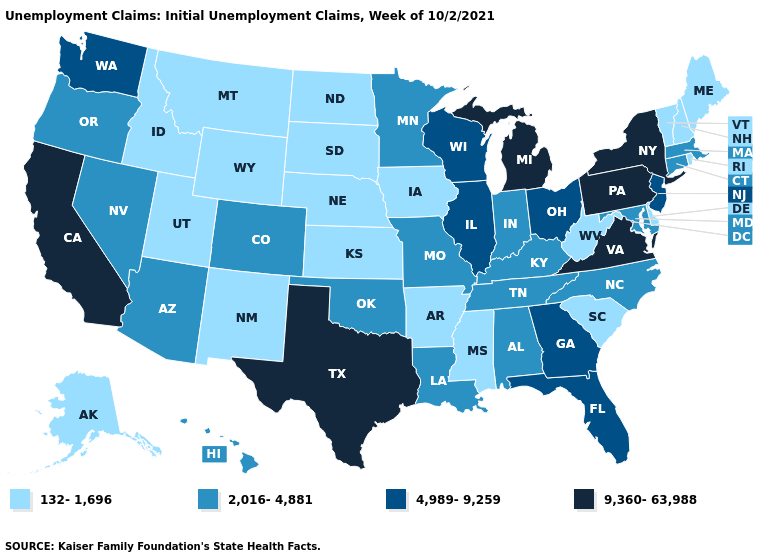Name the states that have a value in the range 9,360-63,988?
Concise answer only. California, Michigan, New York, Pennsylvania, Texas, Virginia. Does North Carolina have the same value as Arizona?
Answer briefly. Yes. Does Texas have the highest value in the South?
Keep it brief. Yes. Which states have the highest value in the USA?
Quick response, please. California, Michigan, New York, Pennsylvania, Texas, Virginia. Is the legend a continuous bar?
Write a very short answer. No. What is the value of Oregon?
Give a very brief answer. 2,016-4,881. Name the states that have a value in the range 4,989-9,259?
Be succinct. Florida, Georgia, Illinois, New Jersey, Ohio, Washington, Wisconsin. Name the states that have a value in the range 2,016-4,881?
Give a very brief answer. Alabama, Arizona, Colorado, Connecticut, Hawaii, Indiana, Kentucky, Louisiana, Maryland, Massachusetts, Minnesota, Missouri, Nevada, North Carolina, Oklahoma, Oregon, Tennessee. Does Idaho have a lower value than Utah?
Short answer required. No. Is the legend a continuous bar?
Quick response, please. No. What is the lowest value in the USA?
Short answer required. 132-1,696. Name the states that have a value in the range 9,360-63,988?
Give a very brief answer. California, Michigan, New York, Pennsylvania, Texas, Virginia. What is the lowest value in the USA?
Concise answer only. 132-1,696. What is the value of Indiana?
Short answer required. 2,016-4,881. 